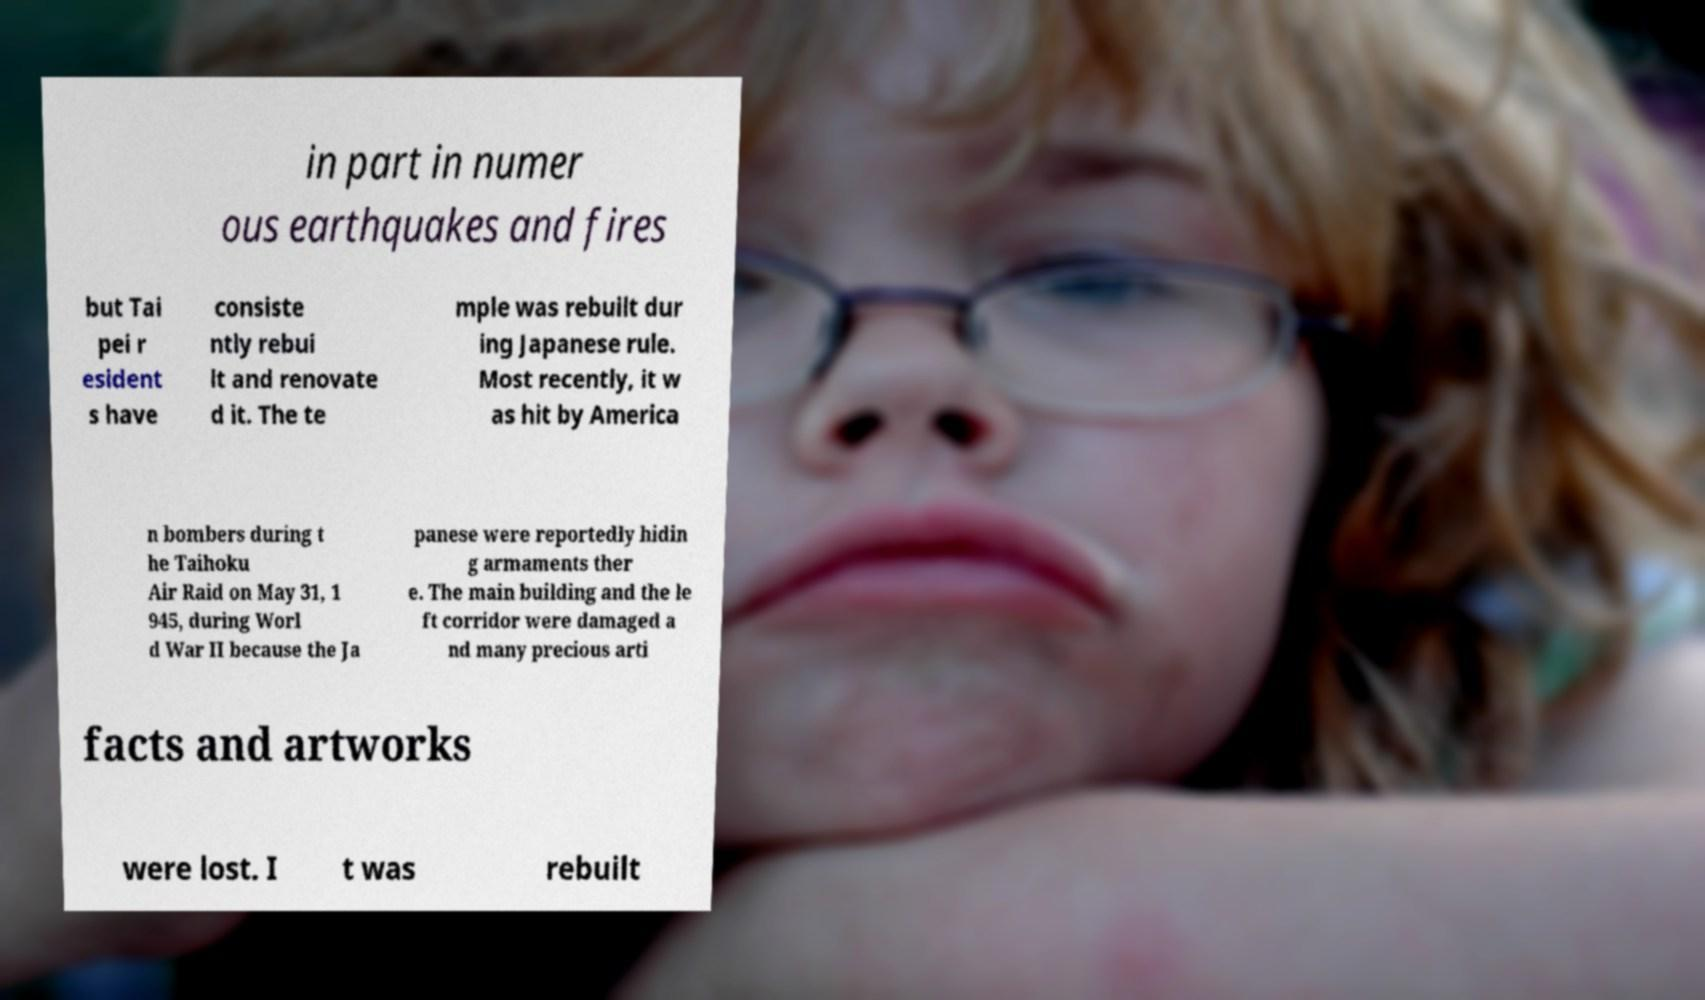Please identify and transcribe the text found in this image. in part in numer ous earthquakes and fires but Tai pei r esident s have consiste ntly rebui lt and renovate d it. The te mple was rebuilt dur ing Japanese rule. Most recently, it w as hit by America n bombers during t he Taihoku Air Raid on May 31, 1 945, during Worl d War II because the Ja panese were reportedly hidin g armaments ther e. The main building and the le ft corridor were damaged a nd many precious arti facts and artworks were lost. I t was rebuilt 